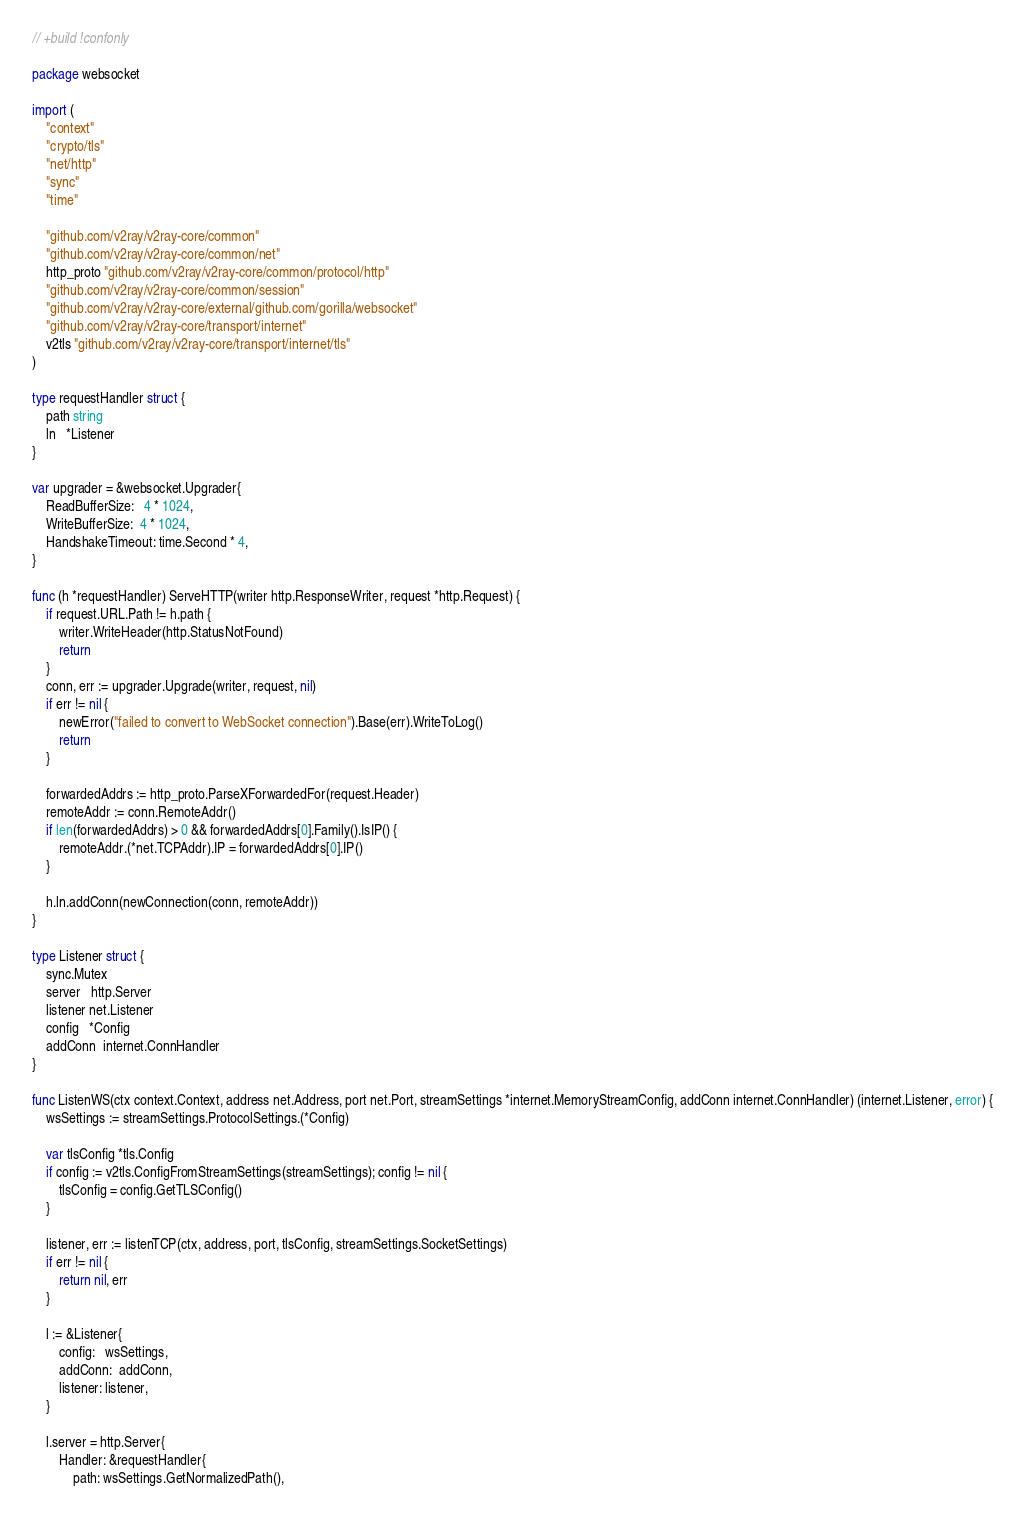Convert code to text. <code><loc_0><loc_0><loc_500><loc_500><_Go_>// +build !confonly

package websocket

import (
	"context"
	"crypto/tls"
	"net/http"
	"sync"
	"time"

	"github.com/v2ray/v2ray-core/common"
	"github.com/v2ray/v2ray-core/common/net"
	http_proto "github.com/v2ray/v2ray-core/common/protocol/http"
	"github.com/v2ray/v2ray-core/common/session"
	"github.com/v2ray/v2ray-core/external/github.com/gorilla/websocket"
	"github.com/v2ray/v2ray-core/transport/internet"
	v2tls "github.com/v2ray/v2ray-core/transport/internet/tls"
)

type requestHandler struct {
	path string
	ln   *Listener
}

var upgrader = &websocket.Upgrader{
	ReadBufferSize:   4 * 1024,
	WriteBufferSize:  4 * 1024,
	HandshakeTimeout: time.Second * 4,
}

func (h *requestHandler) ServeHTTP(writer http.ResponseWriter, request *http.Request) {
	if request.URL.Path != h.path {
		writer.WriteHeader(http.StatusNotFound)
		return
	}
	conn, err := upgrader.Upgrade(writer, request, nil)
	if err != nil {
		newError("failed to convert to WebSocket connection").Base(err).WriteToLog()
		return
	}

	forwardedAddrs := http_proto.ParseXForwardedFor(request.Header)
	remoteAddr := conn.RemoteAddr()
	if len(forwardedAddrs) > 0 && forwardedAddrs[0].Family().IsIP() {
		remoteAddr.(*net.TCPAddr).IP = forwardedAddrs[0].IP()
	}

	h.ln.addConn(newConnection(conn, remoteAddr))
}

type Listener struct {
	sync.Mutex
	server   http.Server
	listener net.Listener
	config   *Config
	addConn  internet.ConnHandler
}

func ListenWS(ctx context.Context, address net.Address, port net.Port, streamSettings *internet.MemoryStreamConfig, addConn internet.ConnHandler) (internet.Listener, error) {
	wsSettings := streamSettings.ProtocolSettings.(*Config)

	var tlsConfig *tls.Config
	if config := v2tls.ConfigFromStreamSettings(streamSettings); config != nil {
		tlsConfig = config.GetTLSConfig()
	}

	listener, err := listenTCP(ctx, address, port, tlsConfig, streamSettings.SocketSettings)
	if err != nil {
		return nil, err
	}

	l := &Listener{
		config:   wsSettings,
		addConn:  addConn,
		listener: listener,
	}

	l.server = http.Server{
		Handler: &requestHandler{
			path: wsSettings.GetNormalizedPath(),</code> 